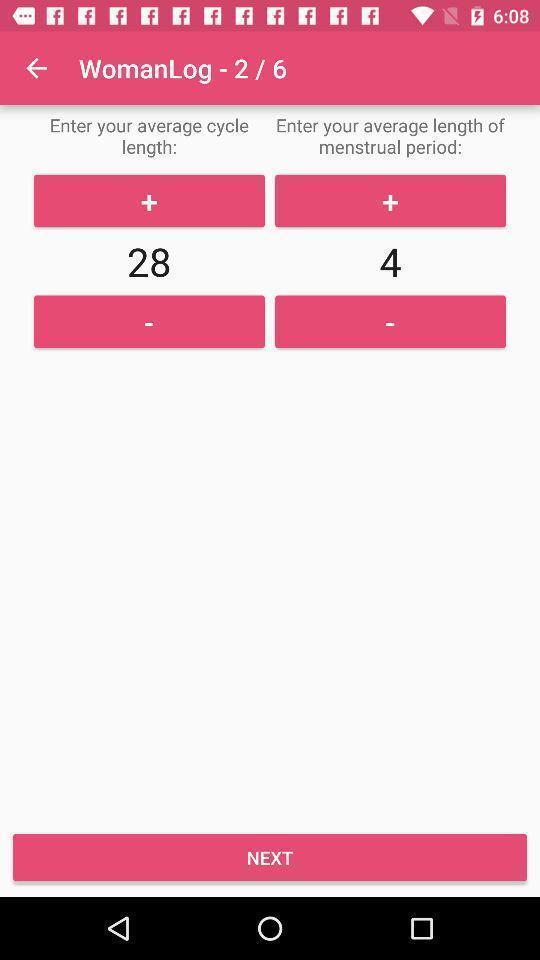Give me a summary of this screen capture. Page showing about women health on app. 